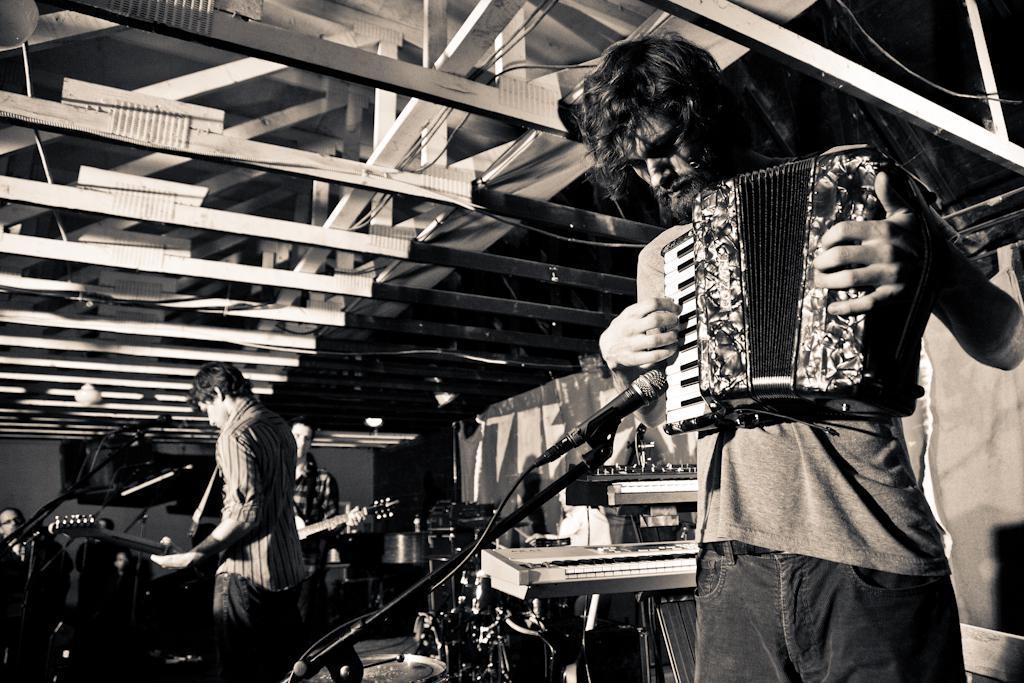In one or two sentences, can you explain what this image depicts? In this image there are people holding the musical instruments. In front of them there are mike's. Around them there are some musical instruments. On top of the image there is a roof top supported by metal rods. In the background of the image there is a wall. 